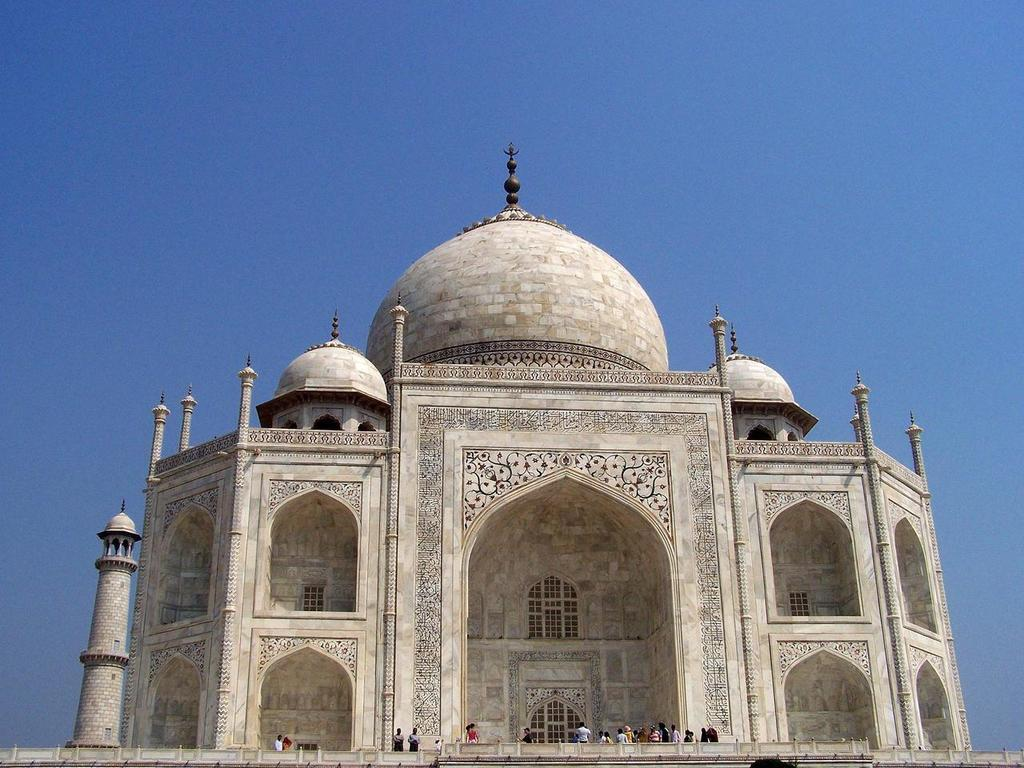What is the main subject of the image? The main subject of the image is groups of people. Where are the people located in the image? The people are standing on a path in the image. What famous landmark can be seen in the image? The "Taj Mahal" is visible in the image. What can be seen in the background of the image? The sky is visible in the image. How many frogs are hopping on the path in the image? There are no frogs present in the image. What type of control system is being used by the people in the image? There is no control system mentioned or visible in the image. 